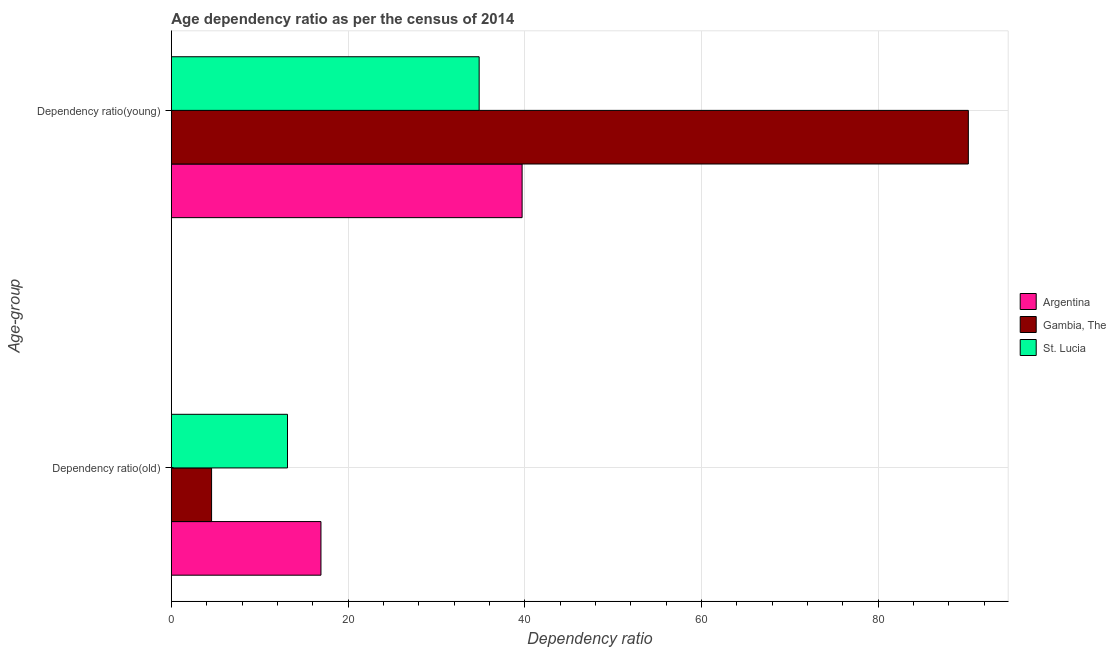How many different coloured bars are there?
Make the answer very short. 3. How many groups of bars are there?
Your answer should be compact. 2. Are the number of bars per tick equal to the number of legend labels?
Offer a terse response. Yes. How many bars are there on the 2nd tick from the bottom?
Offer a terse response. 3. What is the label of the 2nd group of bars from the top?
Your answer should be very brief. Dependency ratio(old). What is the age dependency ratio(young) in Argentina?
Ensure brevity in your answer.  39.7. Across all countries, what is the maximum age dependency ratio(young)?
Offer a very short reply. 90.21. Across all countries, what is the minimum age dependency ratio(old)?
Make the answer very short. 4.55. In which country was the age dependency ratio(young) minimum?
Your response must be concise. St. Lucia. What is the total age dependency ratio(young) in the graph?
Your answer should be very brief. 164.75. What is the difference between the age dependency ratio(old) in Gambia, The and that in Argentina?
Keep it short and to the point. -12.38. What is the difference between the age dependency ratio(young) in St. Lucia and the age dependency ratio(old) in Gambia, The?
Offer a very short reply. 30.29. What is the average age dependency ratio(old) per country?
Provide a short and direct response. 11.54. What is the difference between the age dependency ratio(old) and age dependency ratio(young) in St. Lucia?
Give a very brief answer. -21.69. In how many countries, is the age dependency ratio(old) greater than 72 ?
Provide a succinct answer. 0. What is the ratio of the age dependency ratio(young) in Argentina to that in Gambia, The?
Keep it short and to the point. 0.44. In how many countries, is the age dependency ratio(young) greater than the average age dependency ratio(young) taken over all countries?
Make the answer very short. 1. What does the 1st bar from the top in Dependency ratio(old) represents?
Offer a very short reply. St. Lucia. How many bars are there?
Keep it short and to the point. 6. What is the difference between two consecutive major ticks on the X-axis?
Offer a terse response. 20. Are the values on the major ticks of X-axis written in scientific E-notation?
Give a very brief answer. No. Does the graph contain grids?
Offer a very short reply. Yes. How are the legend labels stacked?
Your answer should be compact. Vertical. What is the title of the graph?
Keep it short and to the point. Age dependency ratio as per the census of 2014. What is the label or title of the X-axis?
Ensure brevity in your answer.  Dependency ratio. What is the label or title of the Y-axis?
Ensure brevity in your answer.  Age-group. What is the Dependency ratio of Argentina in Dependency ratio(old)?
Provide a succinct answer. 16.93. What is the Dependency ratio of Gambia, The in Dependency ratio(old)?
Provide a short and direct response. 4.55. What is the Dependency ratio in St. Lucia in Dependency ratio(old)?
Offer a very short reply. 13.14. What is the Dependency ratio of Argentina in Dependency ratio(young)?
Make the answer very short. 39.7. What is the Dependency ratio of Gambia, The in Dependency ratio(young)?
Provide a succinct answer. 90.21. What is the Dependency ratio in St. Lucia in Dependency ratio(young)?
Keep it short and to the point. 34.84. Across all Age-group, what is the maximum Dependency ratio in Argentina?
Provide a succinct answer. 39.7. Across all Age-group, what is the maximum Dependency ratio of Gambia, The?
Your answer should be very brief. 90.21. Across all Age-group, what is the maximum Dependency ratio in St. Lucia?
Your response must be concise. 34.84. Across all Age-group, what is the minimum Dependency ratio in Argentina?
Provide a succinct answer. 16.93. Across all Age-group, what is the minimum Dependency ratio of Gambia, The?
Provide a short and direct response. 4.55. Across all Age-group, what is the minimum Dependency ratio of St. Lucia?
Your answer should be compact. 13.14. What is the total Dependency ratio in Argentina in the graph?
Offer a terse response. 56.63. What is the total Dependency ratio in Gambia, The in the graph?
Provide a succinct answer. 94.76. What is the total Dependency ratio of St. Lucia in the graph?
Give a very brief answer. 47.98. What is the difference between the Dependency ratio in Argentina in Dependency ratio(old) and that in Dependency ratio(young)?
Your response must be concise. -22.77. What is the difference between the Dependency ratio of Gambia, The in Dependency ratio(old) and that in Dependency ratio(young)?
Give a very brief answer. -85.66. What is the difference between the Dependency ratio in St. Lucia in Dependency ratio(old) and that in Dependency ratio(young)?
Offer a terse response. -21.69. What is the difference between the Dependency ratio in Argentina in Dependency ratio(old) and the Dependency ratio in Gambia, The in Dependency ratio(young)?
Make the answer very short. -73.28. What is the difference between the Dependency ratio in Argentina in Dependency ratio(old) and the Dependency ratio in St. Lucia in Dependency ratio(young)?
Keep it short and to the point. -17.91. What is the difference between the Dependency ratio of Gambia, The in Dependency ratio(old) and the Dependency ratio of St. Lucia in Dependency ratio(young)?
Make the answer very short. -30.29. What is the average Dependency ratio in Argentina per Age-group?
Offer a very short reply. 28.32. What is the average Dependency ratio of Gambia, The per Age-group?
Make the answer very short. 47.38. What is the average Dependency ratio of St. Lucia per Age-group?
Keep it short and to the point. 23.99. What is the difference between the Dependency ratio of Argentina and Dependency ratio of Gambia, The in Dependency ratio(old)?
Offer a very short reply. 12.38. What is the difference between the Dependency ratio in Argentina and Dependency ratio in St. Lucia in Dependency ratio(old)?
Make the answer very short. 3.79. What is the difference between the Dependency ratio in Gambia, The and Dependency ratio in St. Lucia in Dependency ratio(old)?
Your response must be concise. -8.59. What is the difference between the Dependency ratio of Argentina and Dependency ratio of Gambia, The in Dependency ratio(young)?
Keep it short and to the point. -50.51. What is the difference between the Dependency ratio of Argentina and Dependency ratio of St. Lucia in Dependency ratio(young)?
Give a very brief answer. 4.86. What is the difference between the Dependency ratio of Gambia, The and Dependency ratio of St. Lucia in Dependency ratio(young)?
Offer a very short reply. 55.37. What is the ratio of the Dependency ratio of Argentina in Dependency ratio(old) to that in Dependency ratio(young)?
Your answer should be compact. 0.43. What is the ratio of the Dependency ratio of Gambia, The in Dependency ratio(old) to that in Dependency ratio(young)?
Provide a succinct answer. 0.05. What is the ratio of the Dependency ratio in St. Lucia in Dependency ratio(old) to that in Dependency ratio(young)?
Keep it short and to the point. 0.38. What is the difference between the highest and the second highest Dependency ratio of Argentina?
Offer a very short reply. 22.77. What is the difference between the highest and the second highest Dependency ratio of Gambia, The?
Give a very brief answer. 85.66. What is the difference between the highest and the second highest Dependency ratio in St. Lucia?
Your answer should be very brief. 21.69. What is the difference between the highest and the lowest Dependency ratio in Argentina?
Your answer should be compact. 22.77. What is the difference between the highest and the lowest Dependency ratio of Gambia, The?
Make the answer very short. 85.66. What is the difference between the highest and the lowest Dependency ratio of St. Lucia?
Keep it short and to the point. 21.69. 